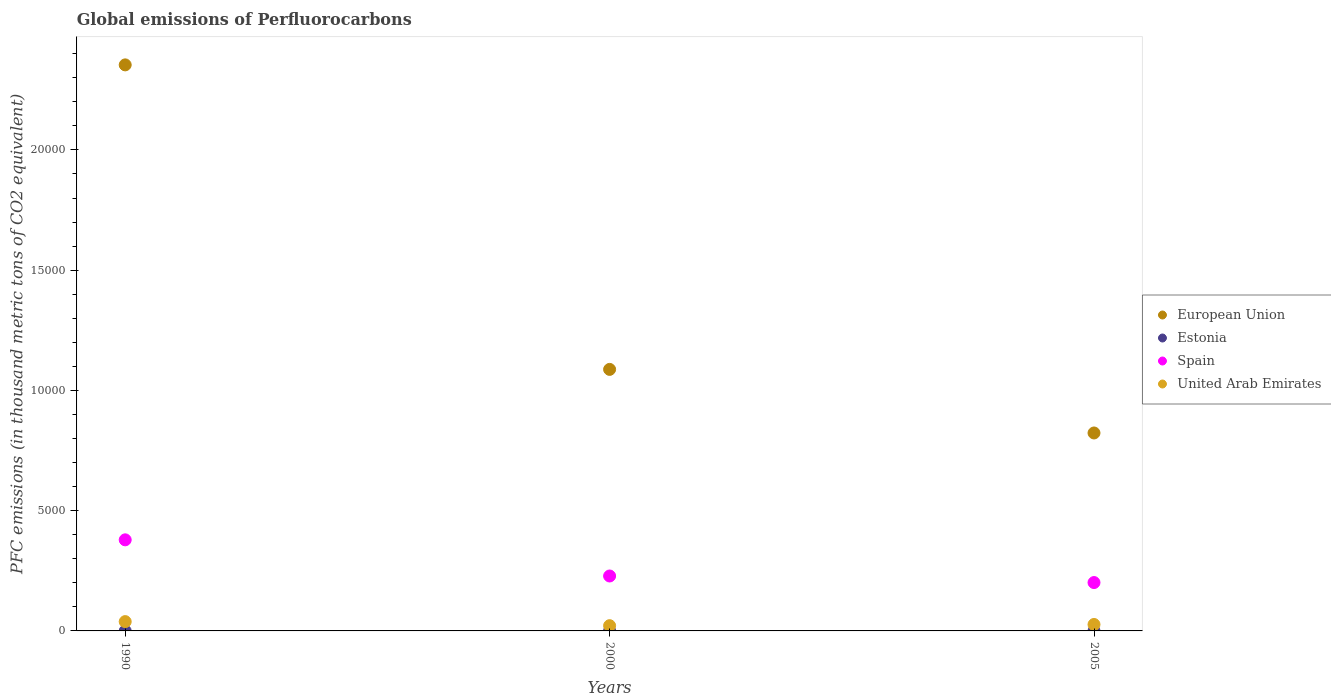How many different coloured dotlines are there?
Your answer should be compact. 4. Is the number of dotlines equal to the number of legend labels?
Offer a terse response. Yes. What is the global emissions of Perfluorocarbons in United Arab Emirates in 2000?
Provide a short and direct response. 218. Across all years, what is the maximum global emissions of Perfluorocarbons in United Arab Emirates?
Provide a succinct answer. 387.3. Across all years, what is the minimum global emissions of Perfluorocarbons in Spain?
Ensure brevity in your answer.  2011. In which year was the global emissions of Perfluorocarbons in Spain minimum?
Ensure brevity in your answer.  2005. What is the difference between the global emissions of Perfluorocarbons in Estonia in 1990 and that in 2000?
Your answer should be compact. -3. What is the difference between the global emissions of Perfluorocarbons in Spain in 2005 and the global emissions of Perfluorocarbons in European Union in 2000?
Your response must be concise. -8863.6. What is the average global emissions of Perfluorocarbons in Estonia per year?
Your answer should be very brief. 2.47. In the year 2005, what is the difference between the global emissions of Perfluorocarbons in Spain and global emissions of Perfluorocarbons in European Union?
Make the answer very short. -6219.79. What is the ratio of the global emissions of Perfluorocarbons in United Arab Emirates in 1990 to that in 2000?
Give a very brief answer. 1.78. What is the difference between the highest and the second highest global emissions of Perfluorocarbons in United Arab Emirates?
Offer a terse response. 119.4. What is the difference between the highest and the lowest global emissions of Perfluorocarbons in United Arab Emirates?
Provide a short and direct response. 169.3. How many dotlines are there?
Ensure brevity in your answer.  4. How many years are there in the graph?
Your answer should be compact. 3. What is the difference between two consecutive major ticks on the Y-axis?
Your answer should be compact. 5000. What is the title of the graph?
Give a very brief answer. Global emissions of Perfluorocarbons. What is the label or title of the X-axis?
Provide a succinct answer. Years. What is the label or title of the Y-axis?
Provide a short and direct response. PFC emissions (in thousand metric tons of CO2 equivalent). What is the PFC emissions (in thousand metric tons of CO2 equivalent) in European Union in 1990?
Offer a terse response. 2.35e+04. What is the PFC emissions (in thousand metric tons of CO2 equivalent) in Estonia in 1990?
Your answer should be compact. 0.5. What is the PFC emissions (in thousand metric tons of CO2 equivalent) in Spain in 1990?
Provide a succinct answer. 3787.4. What is the PFC emissions (in thousand metric tons of CO2 equivalent) in United Arab Emirates in 1990?
Offer a very short reply. 387.3. What is the PFC emissions (in thousand metric tons of CO2 equivalent) in European Union in 2000?
Provide a short and direct response. 1.09e+04. What is the PFC emissions (in thousand metric tons of CO2 equivalent) of Spain in 2000?
Keep it short and to the point. 2283.8. What is the PFC emissions (in thousand metric tons of CO2 equivalent) of United Arab Emirates in 2000?
Offer a terse response. 218. What is the PFC emissions (in thousand metric tons of CO2 equivalent) of European Union in 2005?
Offer a terse response. 8230.79. What is the PFC emissions (in thousand metric tons of CO2 equivalent) in Estonia in 2005?
Keep it short and to the point. 3.4. What is the PFC emissions (in thousand metric tons of CO2 equivalent) in Spain in 2005?
Your response must be concise. 2011. What is the PFC emissions (in thousand metric tons of CO2 equivalent) in United Arab Emirates in 2005?
Ensure brevity in your answer.  267.9. Across all years, what is the maximum PFC emissions (in thousand metric tons of CO2 equivalent) in European Union?
Your answer should be compact. 2.35e+04. Across all years, what is the maximum PFC emissions (in thousand metric tons of CO2 equivalent) of Spain?
Your response must be concise. 3787.4. Across all years, what is the maximum PFC emissions (in thousand metric tons of CO2 equivalent) in United Arab Emirates?
Make the answer very short. 387.3. Across all years, what is the minimum PFC emissions (in thousand metric tons of CO2 equivalent) in European Union?
Offer a terse response. 8230.79. Across all years, what is the minimum PFC emissions (in thousand metric tons of CO2 equivalent) in Estonia?
Provide a succinct answer. 0.5. Across all years, what is the minimum PFC emissions (in thousand metric tons of CO2 equivalent) of Spain?
Ensure brevity in your answer.  2011. Across all years, what is the minimum PFC emissions (in thousand metric tons of CO2 equivalent) of United Arab Emirates?
Give a very brief answer. 218. What is the total PFC emissions (in thousand metric tons of CO2 equivalent) in European Union in the graph?
Ensure brevity in your answer.  4.26e+04. What is the total PFC emissions (in thousand metric tons of CO2 equivalent) in Estonia in the graph?
Your answer should be very brief. 7.4. What is the total PFC emissions (in thousand metric tons of CO2 equivalent) in Spain in the graph?
Give a very brief answer. 8082.2. What is the total PFC emissions (in thousand metric tons of CO2 equivalent) in United Arab Emirates in the graph?
Provide a succinct answer. 873.2. What is the difference between the PFC emissions (in thousand metric tons of CO2 equivalent) of European Union in 1990 and that in 2000?
Give a very brief answer. 1.27e+04. What is the difference between the PFC emissions (in thousand metric tons of CO2 equivalent) in Spain in 1990 and that in 2000?
Provide a short and direct response. 1503.6. What is the difference between the PFC emissions (in thousand metric tons of CO2 equivalent) in United Arab Emirates in 1990 and that in 2000?
Your response must be concise. 169.3. What is the difference between the PFC emissions (in thousand metric tons of CO2 equivalent) in European Union in 1990 and that in 2005?
Your answer should be very brief. 1.53e+04. What is the difference between the PFC emissions (in thousand metric tons of CO2 equivalent) in Spain in 1990 and that in 2005?
Give a very brief answer. 1776.4. What is the difference between the PFC emissions (in thousand metric tons of CO2 equivalent) in United Arab Emirates in 1990 and that in 2005?
Provide a short and direct response. 119.4. What is the difference between the PFC emissions (in thousand metric tons of CO2 equivalent) of European Union in 2000 and that in 2005?
Ensure brevity in your answer.  2643.81. What is the difference between the PFC emissions (in thousand metric tons of CO2 equivalent) in Estonia in 2000 and that in 2005?
Offer a terse response. 0.1. What is the difference between the PFC emissions (in thousand metric tons of CO2 equivalent) in Spain in 2000 and that in 2005?
Your answer should be very brief. 272.8. What is the difference between the PFC emissions (in thousand metric tons of CO2 equivalent) of United Arab Emirates in 2000 and that in 2005?
Offer a terse response. -49.9. What is the difference between the PFC emissions (in thousand metric tons of CO2 equivalent) in European Union in 1990 and the PFC emissions (in thousand metric tons of CO2 equivalent) in Estonia in 2000?
Ensure brevity in your answer.  2.35e+04. What is the difference between the PFC emissions (in thousand metric tons of CO2 equivalent) of European Union in 1990 and the PFC emissions (in thousand metric tons of CO2 equivalent) of Spain in 2000?
Provide a succinct answer. 2.13e+04. What is the difference between the PFC emissions (in thousand metric tons of CO2 equivalent) in European Union in 1990 and the PFC emissions (in thousand metric tons of CO2 equivalent) in United Arab Emirates in 2000?
Make the answer very short. 2.33e+04. What is the difference between the PFC emissions (in thousand metric tons of CO2 equivalent) of Estonia in 1990 and the PFC emissions (in thousand metric tons of CO2 equivalent) of Spain in 2000?
Ensure brevity in your answer.  -2283.3. What is the difference between the PFC emissions (in thousand metric tons of CO2 equivalent) in Estonia in 1990 and the PFC emissions (in thousand metric tons of CO2 equivalent) in United Arab Emirates in 2000?
Provide a short and direct response. -217.5. What is the difference between the PFC emissions (in thousand metric tons of CO2 equivalent) of Spain in 1990 and the PFC emissions (in thousand metric tons of CO2 equivalent) of United Arab Emirates in 2000?
Keep it short and to the point. 3569.4. What is the difference between the PFC emissions (in thousand metric tons of CO2 equivalent) of European Union in 1990 and the PFC emissions (in thousand metric tons of CO2 equivalent) of Estonia in 2005?
Your response must be concise. 2.35e+04. What is the difference between the PFC emissions (in thousand metric tons of CO2 equivalent) in European Union in 1990 and the PFC emissions (in thousand metric tons of CO2 equivalent) in Spain in 2005?
Your response must be concise. 2.15e+04. What is the difference between the PFC emissions (in thousand metric tons of CO2 equivalent) of European Union in 1990 and the PFC emissions (in thousand metric tons of CO2 equivalent) of United Arab Emirates in 2005?
Give a very brief answer. 2.33e+04. What is the difference between the PFC emissions (in thousand metric tons of CO2 equivalent) of Estonia in 1990 and the PFC emissions (in thousand metric tons of CO2 equivalent) of Spain in 2005?
Offer a very short reply. -2010.5. What is the difference between the PFC emissions (in thousand metric tons of CO2 equivalent) in Estonia in 1990 and the PFC emissions (in thousand metric tons of CO2 equivalent) in United Arab Emirates in 2005?
Provide a short and direct response. -267.4. What is the difference between the PFC emissions (in thousand metric tons of CO2 equivalent) in Spain in 1990 and the PFC emissions (in thousand metric tons of CO2 equivalent) in United Arab Emirates in 2005?
Keep it short and to the point. 3519.5. What is the difference between the PFC emissions (in thousand metric tons of CO2 equivalent) of European Union in 2000 and the PFC emissions (in thousand metric tons of CO2 equivalent) of Estonia in 2005?
Your answer should be very brief. 1.09e+04. What is the difference between the PFC emissions (in thousand metric tons of CO2 equivalent) of European Union in 2000 and the PFC emissions (in thousand metric tons of CO2 equivalent) of Spain in 2005?
Your answer should be very brief. 8863.6. What is the difference between the PFC emissions (in thousand metric tons of CO2 equivalent) in European Union in 2000 and the PFC emissions (in thousand metric tons of CO2 equivalent) in United Arab Emirates in 2005?
Make the answer very short. 1.06e+04. What is the difference between the PFC emissions (in thousand metric tons of CO2 equivalent) in Estonia in 2000 and the PFC emissions (in thousand metric tons of CO2 equivalent) in Spain in 2005?
Your answer should be very brief. -2007.5. What is the difference between the PFC emissions (in thousand metric tons of CO2 equivalent) of Estonia in 2000 and the PFC emissions (in thousand metric tons of CO2 equivalent) of United Arab Emirates in 2005?
Your answer should be very brief. -264.4. What is the difference between the PFC emissions (in thousand metric tons of CO2 equivalent) of Spain in 2000 and the PFC emissions (in thousand metric tons of CO2 equivalent) of United Arab Emirates in 2005?
Give a very brief answer. 2015.9. What is the average PFC emissions (in thousand metric tons of CO2 equivalent) in European Union per year?
Ensure brevity in your answer.  1.42e+04. What is the average PFC emissions (in thousand metric tons of CO2 equivalent) of Estonia per year?
Offer a terse response. 2.47. What is the average PFC emissions (in thousand metric tons of CO2 equivalent) of Spain per year?
Ensure brevity in your answer.  2694.07. What is the average PFC emissions (in thousand metric tons of CO2 equivalent) in United Arab Emirates per year?
Provide a short and direct response. 291.07. In the year 1990, what is the difference between the PFC emissions (in thousand metric tons of CO2 equivalent) in European Union and PFC emissions (in thousand metric tons of CO2 equivalent) in Estonia?
Your answer should be very brief. 2.35e+04. In the year 1990, what is the difference between the PFC emissions (in thousand metric tons of CO2 equivalent) in European Union and PFC emissions (in thousand metric tons of CO2 equivalent) in Spain?
Ensure brevity in your answer.  1.97e+04. In the year 1990, what is the difference between the PFC emissions (in thousand metric tons of CO2 equivalent) in European Union and PFC emissions (in thousand metric tons of CO2 equivalent) in United Arab Emirates?
Offer a very short reply. 2.31e+04. In the year 1990, what is the difference between the PFC emissions (in thousand metric tons of CO2 equivalent) in Estonia and PFC emissions (in thousand metric tons of CO2 equivalent) in Spain?
Provide a short and direct response. -3786.9. In the year 1990, what is the difference between the PFC emissions (in thousand metric tons of CO2 equivalent) in Estonia and PFC emissions (in thousand metric tons of CO2 equivalent) in United Arab Emirates?
Make the answer very short. -386.8. In the year 1990, what is the difference between the PFC emissions (in thousand metric tons of CO2 equivalent) in Spain and PFC emissions (in thousand metric tons of CO2 equivalent) in United Arab Emirates?
Your answer should be very brief. 3400.1. In the year 2000, what is the difference between the PFC emissions (in thousand metric tons of CO2 equivalent) in European Union and PFC emissions (in thousand metric tons of CO2 equivalent) in Estonia?
Ensure brevity in your answer.  1.09e+04. In the year 2000, what is the difference between the PFC emissions (in thousand metric tons of CO2 equivalent) in European Union and PFC emissions (in thousand metric tons of CO2 equivalent) in Spain?
Your answer should be compact. 8590.8. In the year 2000, what is the difference between the PFC emissions (in thousand metric tons of CO2 equivalent) in European Union and PFC emissions (in thousand metric tons of CO2 equivalent) in United Arab Emirates?
Your response must be concise. 1.07e+04. In the year 2000, what is the difference between the PFC emissions (in thousand metric tons of CO2 equivalent) of Estonia and PFC emissions (in thousand metric tons of CO2 equivalent) of Spain?
Keep it short and to the point. -2280.3. In the year 2000, what is the difference between the PFC emissions (in thousand metric tons of CO2 equivalent) in Estonia and PFC emissions (in thousand metric tons of CO2 equivalent) in United Arab Emirates?
Offer a terse response. -214.5. In the year 2000, what is the difference between the PFC emissions (in thousand metric tons of CO2 equivalent) of Spain and PFC emissions (in thousand metric tons of CO2 equivalent) of United Arab Emirates?
Ensure brevity in your answer.  2065.8. In the year 2005, what is the difference between the PFC emissions (in thousand metric tons of CO2 equivalent) in European Union and PFC emissions (in thousand metric tons of CO2 equivalent) in Estonia?
Make the answer very short. 8227.39. In the year 2005, what is the difference between the PFC emissions (in thousand metric tons of CO2 equivalent) in European Union and PFC emissions (in thousand metric tons of CO2 equivalent) in Spain?
Provide a succinct answer. 6219.79. In the year 2005, what is the difference between the PFC emissions (in thousand metric tons of CO2 equivalent) in European Union and PFC emissions (in thousand metric tons of CO2 equivalent) in United Arab Emirates?
Your response must be concise. 7962.89. In the year 2005, what is the difference between the PFC emissions (in thousand metric tons of CO2 equivalent) in Estonia and PFC emissions (in thousand metric tons of CO2 equivalent) in Spain?
Give a very brief answer. -2007.6. In the year 2005, what is the difference between the PFC emissions (in thousand metric tons of CO2 equivalent) in Estonia and PFC emissions (in thousand metric tons of CO2 equivalent) in United Arab Emirates?
Give a very brief answer. -264.5. In the year 2005, what is the difference between the PFC emissions (in thousand metric tons of CO2 equivalent) in Spain and PFC emissions (in thousand metric tons of CO2 equivalent) in United Arab Emirates?
Provide a succinct answer. 1743.1. What is the ratio of the PFC emissions (in thousand metric tons of CO2 equivalent) in European Union in 1990 to that in 2000?
Your response must be concise. 2.16. What is the ratio of the PFC emissions (in thousand metric tons of CO2 equivalent) in Estonia in 1990 to that in 2000?
Your response must be concise. 0.14. What is the ratio of the PFC emissions (in thousand metric tons of CO2 equivalent) of Spain in 1990 to that in 2000?
Offer a terse response. 1.66. What is the ratio of the PFC emissions (in thousand metric tons of CO2 equivalent) of United Arab Emirates in 1990 to that in 2000?
Your answer should be very brief. 1.78. What is the ratio of the PFC emissions (in thousand metric tons of CO2 equivalent) of European Union in 1990 to that in 2005?
Keep it short and to the point. 2.86. What is the ratio of the PFC emissions (in thousand metric tons of CO2 equivalent) of Estonia in 1990 to that in 2005?
Provide a short and direct response. 0.15. What is the ratio of the PFC emissions (in thousand metric tons of CO2 equivalent) in Spain in 1990 to that in 2005?
Your answer should be very brief. 1.88. What is the ratio of the PFC emissions (in thousand metric tons of CO2 equivalent) in United Arab Emirates in 1990 to that in 2005?
Give a very brief answer. 1.45. What is the ratio of the PFC emissions (in thousand metric tons of CO2 equivalent) in European Union in 2000 to that in 2005?
Offer a terse response. 1.32. What is the ratio of the PFC emissions (in thousand metric tons of CO2 equivalent) in Estonia in 2000 to that in 2005?
Make the answer very short. 1.03. What is the ratio of the PFC emissions (in thousand metric tons of CO2 equivalent) in Spain in 2000 to that in 2005?
Make the answer very short. 1.14. What is the ratio of the PFC emissions (in thousand metric tons of CO2 equivalent) in United Arab Emirates in 2000 to that in 2005?
Provide a succinct answer. 0.81. What is the difference between the highest and the second highest PFC emissions (in thousand metric tons of CO2 equivalent) of European Union?
Give a very brief answer. 1.27e+04. What is the difference between the highest and the second highest PFC emissions (in thousand metric tons of CO2 equivalent) in Estonia?
Your response must be concise. 0.1. What is the difference between the highest and the second highest PFC emissions (in thousand metric tons of CO2 equivalent) of Spain?
Your answer should be compact. 1503.6. What is the difference between the highest and the second highest PFC emissions (in thousand metric tons of CO2 equivalent) of United Arab Emirates?
Give a very brief answer. 119.4. What is the difference between the highest and the lowest PFC emissions (in thousand metric tons of CO2 equivalent) of European Union?
Offer a very short reply. 1.53e+04. What is the difference between the highest and the lowest PFC emissions (in thousand metric tons of CO2 equivalent) of Spain?
Ensure brevity in your answer.  1776.4. What is the difference between the highest and the lowest PFC emissions (in thousand metric tons of CO2 equivalent) of United Arab Emirates?
Make the answer very short. 169.3. 